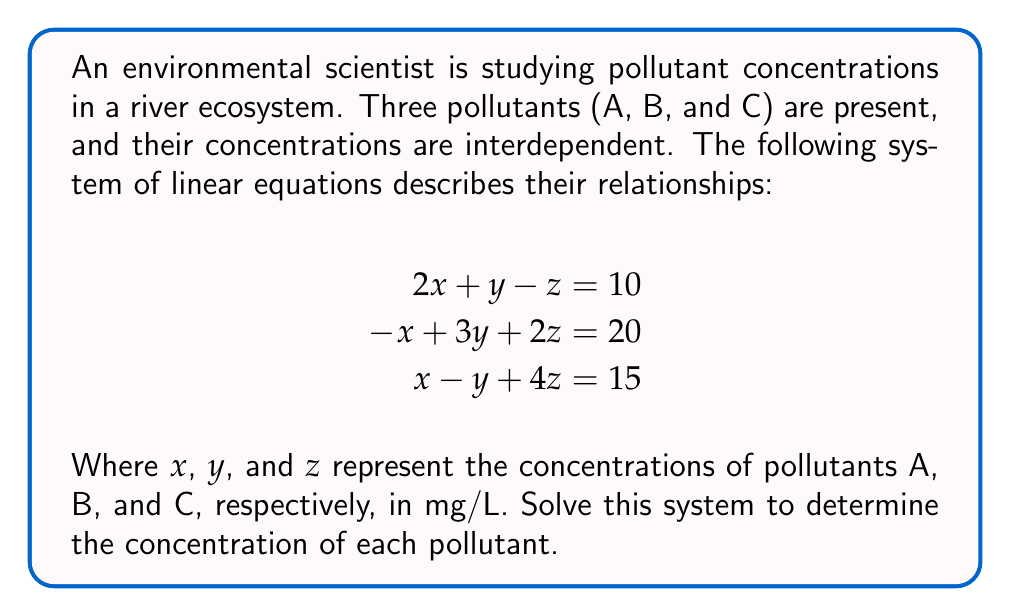What is the answer to this math problem? To solve this system of linear equations, we'll use the Gaussian elimination method:

1) First, write the augmented matrix:
   $$\begin{bmatrix}
   2 & 1 & -1 & 10 \\
   -1 & 3 & 2 & 20 \\
   1 & -1 & 4 & 15
   \end{bmatrix}$$

2) Multiply the first row by 1/2 and add it to the second row:
   $$\begin{bmatrix}
   2 & 1 & -1 & 10 \\
   0 & 3.5 & 1.5 & 25 \\
   1 & -1 & 4 & 15
   \end{bmatrix}$$

3) Subtract the first row from the third row:
   $$\begin{bmatrix}
   2 & 1 & -1 & 10 \\
   0 & 3.5 & 1.5 & 25 \\
   -1 & -2 & 5 & 5
   \end{bmatrix}$$

4) Multiply the second row by 2/7 and subtract it from the third row:
   $$\begin{bmatrix}
   2 & 1 & -1 & 10 \\
   0 & 3.5 & 1.5 & 25 \\
   -1 & 0 & 4.14 & -2.14
   \end{bmatrix}$$

5) Now we have an upper triangular matrix. Solve for z:
   $4.14z = -2.14 + 1$
   $z = -1.14/4.14 \approx -0.28$

6) Substitute z into the second equation:
   $3.5y + 1.5(-0.28) = 25$
   $3.5y = 25.42$
   $y \approx 7.26$

7) Finally, substitute y and z into the first equation:
   $2x + 7.26 - (-0.28) = 10$
   $2x = 2.46$
   $x = 1.23$

Therefore, the concentrations are:
Pollutant A (x): 1.23 mg/L
Pollutant B (y): 7.26 mg/L
Pollutant C (z): -0.28 mg/L
Answer: $x = 1.23$, $y = 7.26$, $z = -0.28$ 